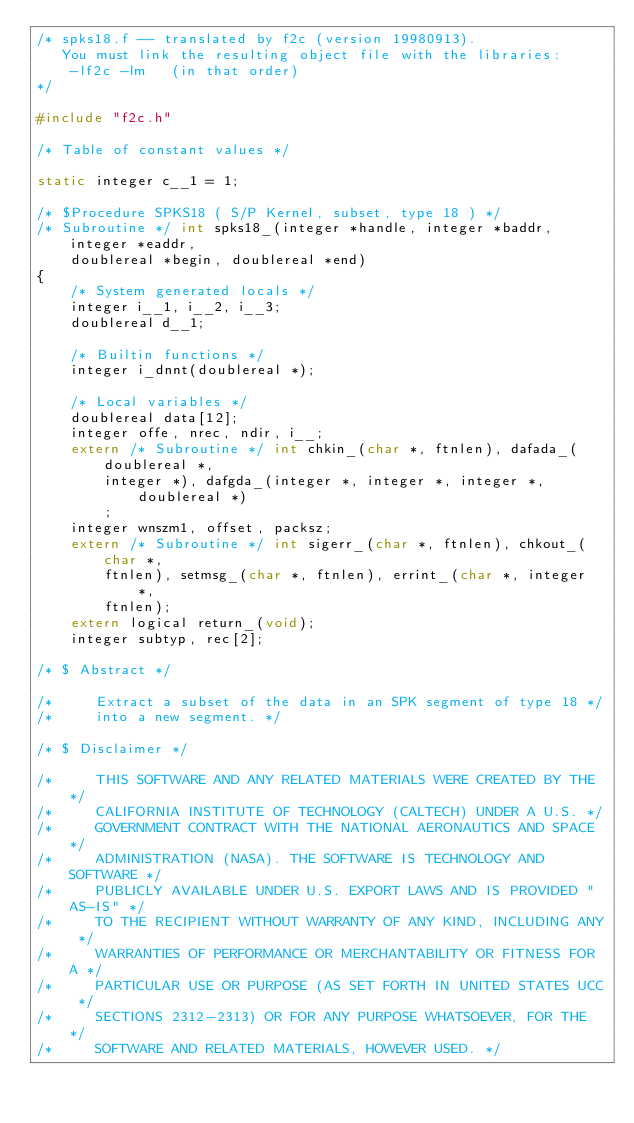Convert code to text. <code><loc_0><loc_0><loc_500><loc_500><_C_>/* spks18.f -- translated by f2c (version 19980913).
   You must link the resulting object file with the libraries:
	-lf2c -lm   (in that order)
*/

#include "f2c.h"

/* Table of constant values */

static integer c__1 = 1;

/* $Procedure SPKS18 ( S/P Kernel, subset, type 18 ) */
/* Subroutine */ int spks18_(integer *handle, integer *baddr, integer *eaddr, 
	doublereal *begin, doublereal *end)
{
    /* System generated locals */
    integer i__1, i__2, i__3;
    doublereal d__1;

    /* Builtin functions */
    integer i_dnnt(doublereal *);

    /* Local variables */
    doublereal data[12];
    integer offe, nrec, ndir, i__;
    extern /* Subroutine */ int chkin_(char *, ftnlen), dafada_(doublereal *, 
	    integer *), dafgda_(integer *, integer *, integer *, doublereal *)
	    ;
    integer wnszm1, offset, packsz;
    extern /* Subroutine */ int sigerr_(char *, ftnlen), chkout_(char *, 
	    ftnlen), setmsg_(char *, ftnlen), errint_(char *, integer *, 
	    ftnlen);
    extern logical return_(void);
    integer subtyp, rec[2];

/* $ Abstract */

/*     Extract a subset of the data in an SPK segment of type 18 */
/*     into a new segment. */

/* $ Disclaimer */

/*     THIS SOFTWARE AND ANY RELATED MATERIALS WERE CREATED BY THE */
/*     CALIFORNIA INSTITUTE OF TECHNOLOGY (CALTECH) UNDER A U.S. */
/*     GOVERNMENT CONTRACT WITH THE NATIONAL AERONAUTICS AND SPACE */
/*     ADMINISTRATION (NASA). THE SOFTWARE IS TECHNOLOGY AND SOFTWARE */
/*     PUBLICLY AVAILABLE UNDER U.S. EXPORT LAWS AND IS PROVIDED "AS-IS" */
/*     TO THE RECIPIENT WITHOUT WARRANTY OF ANY KIND, INCLUDING ANY */
/*     WARRANTIES OF PERFORMANCE OR MERCHANTABILITY OR FITNESS FOR A */
/*     PARTICULAR USE OR PURPOSE (AS SET FORTH IN UNITED STATES UCC */
/*     SECTIONS 2312-2313) OR FOR ANY PURPOSE WHATSOEVER, FOR THE */
/*     SOFTWARE AND RELATED MATERIALS, HOWEVER USED. */
</code> 